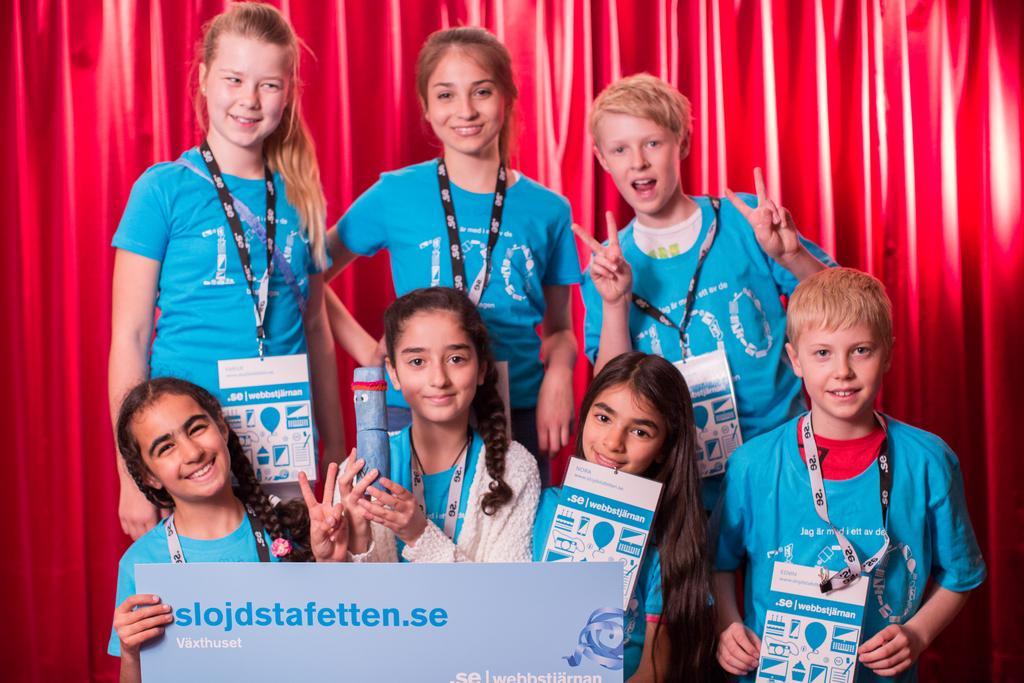Describe this image in one or two sentences. In the backdrop there is a curtain. We can see girls and boys wearing blue t-shirts and all are smiling. 